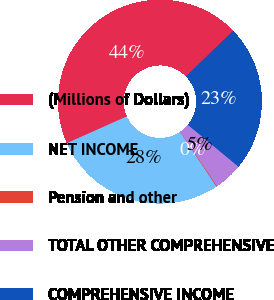Convert chart. <chart><loc_0><loc_0><loc_500><loc_500><pie_chart><fcel>(Millions of Dollars)<fcel>NET INCOME<fcel>Pension and other<fcel>TOTAL OTHER COMPREHENSIVE<fcel>COMPREHENSIVE INCOME<nl><fcel>44.44%<fcel>27.67%<fcel>0.11%<fcel>4.54%<fcel>23.24%<nl></chart> 